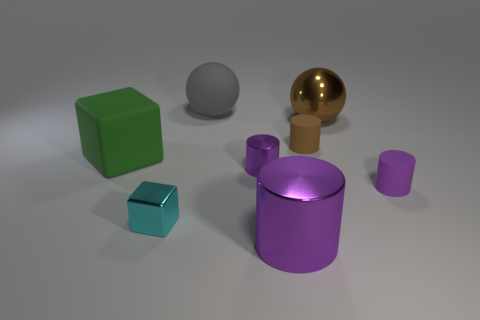Add 1 small brown cylinders. How many objects exist? 9 Subtract all small brown matte cylinders. How many cylinders are left? 3 Subtract 2 cylinders. How many cylinders are left? 2 Subtract all brown spheres. How many purple cylinders are left? 3 Subtract all balls. How many objects are left? 6 Subtract all brown cylinders. Subtract all gray blocks. How many cylinders are left? 3 Subtract all purple things. Subtract all cyan metallic objects. How many objects are left? 4 Add 2 big matte balls. How many big matte balls are left? 3 Add 1 large yellow metallic blocks. How many large yellow metallic blocks exist? 1 Subtract all brown cylinders. How many cylinders are left? 3 